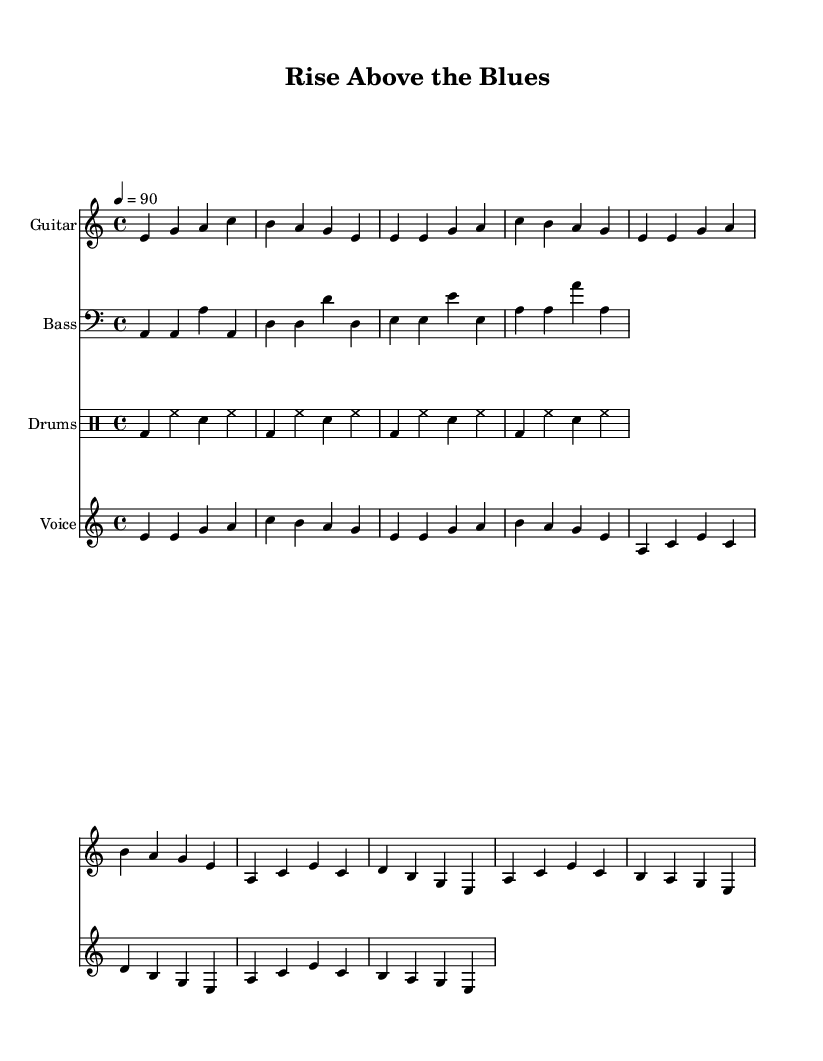What is the key signature of this music? The key signature indicated at the beginning of the score is A minor, which has no sharps or flats.
Answer: A minor What is the time signature of this music? The time signature found near the beginning of the score is four beats per measure, indicating a standard 4/4 time.
Answer: 4/4 What is the tempo marking of this piece? The tempo marking specifies a speed of 90 BPM, which indicates the piece should be played moderately fast.
Answer: 90 How many lines are in the verse lyrics? The verse lyrics are written across four lines, with each line representing a distinct musical phrase.
Answer: Four lines What is the main theme of the chorus lyrics? The chorus emphasizes self-care and personal empowerment, reflecting a positive message about rising above challenges.
Answer: Self-care and empowerment How many instruments are featured in this score? The score includes four distinct musical parts: guitar, bass, drums, and voice, making it a total of four instruments.
Answer: Four instruments What blues element is emphasized in the lyrics? The lyrics exhibit a strong focus on personal empowerment and mental wellness, which are central themes in modern electric blues music.
Answer: Personal empowerment 